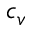<formula> <loc_0><loc_0><loc_500><loc_500>c _ { v }</formula> 